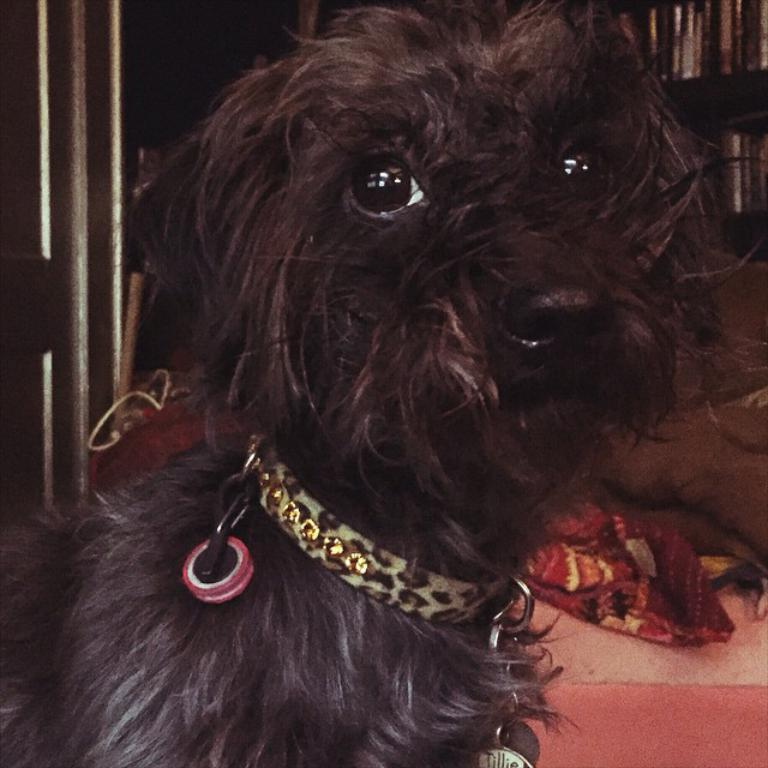What is the main subject in the center of the image? There is a dog in the center of the image. Is there anything unusual about the dog's appearance? Yes, the dog has a belt around its neck. What can be seen in the background of the image? There is a cloth visible in the background of the image. Where is the father standing in the image? There is no father present in the image; it only features a dog with a belt around its neck and a cloth in the background. 